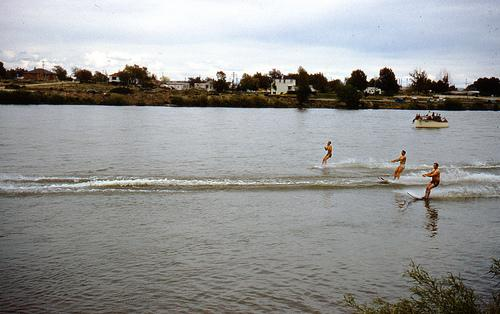Question: where are skis?
Choices:
A. On the rack.
B. On the water.
C. On the backpack.
D. On the top of the truck.
Answer with the letter. Answer: B Question: when was picture taken?
Choices:
A. In the evening.
B. At lunch.
C. During daylight.
D. Morning.
Answer with the letter. Answer: C Question: what are people doing?
Choices:
A. Frolicking.
B. Hugging.
C. Walking.
D. Water skiing.
Answer with the letter. Answer: D Question: who is in picture?
Choices:
A. Bears.
B. Tourists.
C. Troops.
D. Water skiers.
Answer with the letter. Answer: D Question: what is condition of sky?
Choices:
A. Clear.
B. Snowy.
C. Foggy.
D. Cloudy.
Answer with the letter. Answer: A Question: how many skiers?
Choices:
A. Two.
B. Nine.
C. Six.
D. Three.
Answer with the letter. Answer: D 